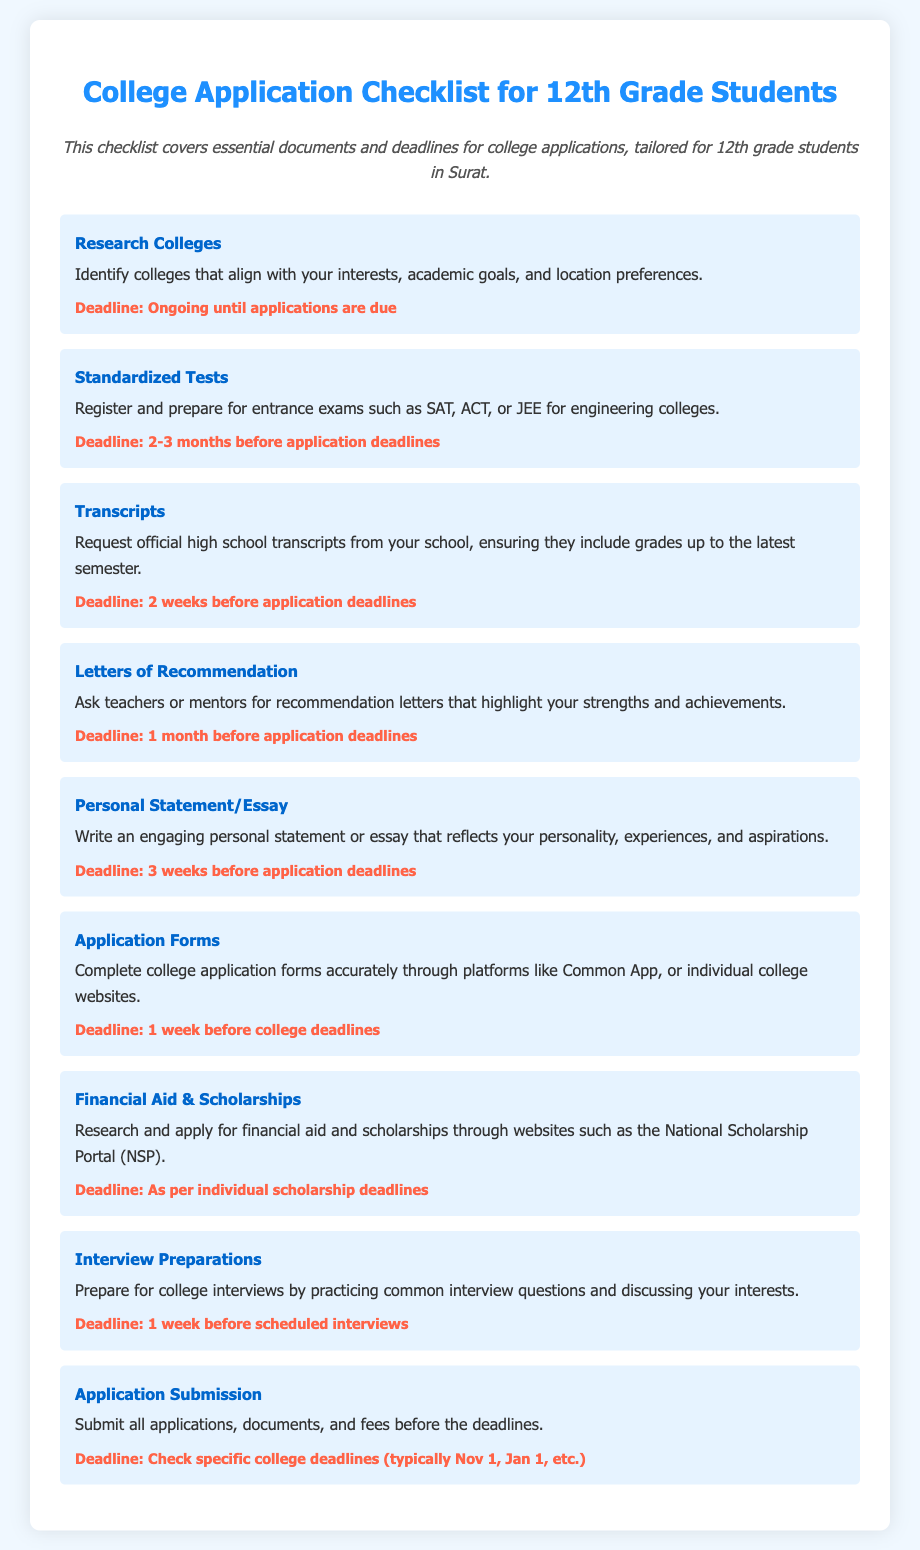What is the first item in the checklist? The first item is about researching colleges to identify those that fit your interests.
Answer: Research Colleges What is the deadline for standardized tests preparation? The deadline for preparing for standardized tests is 2-3 months before application deadlines.
Answer: 2-3 months before application deadlines How long before application deadlines should you request transcripts? You should request transcripts 2 weeks before application deadlines.
Answer: 2 weeks before application deadlines What document is needed 1 month before application deadlines? One month before application deadlines, letters of recommendation are needed.
Answer: Letters of Recommendation When should the personal statement or essay be completed? The personal statement or essay should be completed 3 weeks before application deadlines.
Answer: 3 weeks before application deadlines Which item in the checklist involves submitting fees? The item that involves submitting fees is the Application Submission.
Answer: Application Submission What is the purpose of the financial aid and scholarships item? The purpose is to research and apply for financial aid and scholarships.
Answer: Research and apply for financial aid and scholarships How should the college application forms be completed? College application forms should be completed accurately through platforms like Common App or individual college websites.
Answer: Accurately through platforms like Common App What is the last step in the college application checklist? The last step is to submit all applications, documents, and fees before the deadlines.
Answer: Submit all applications, documents, and fees before the deadlines 